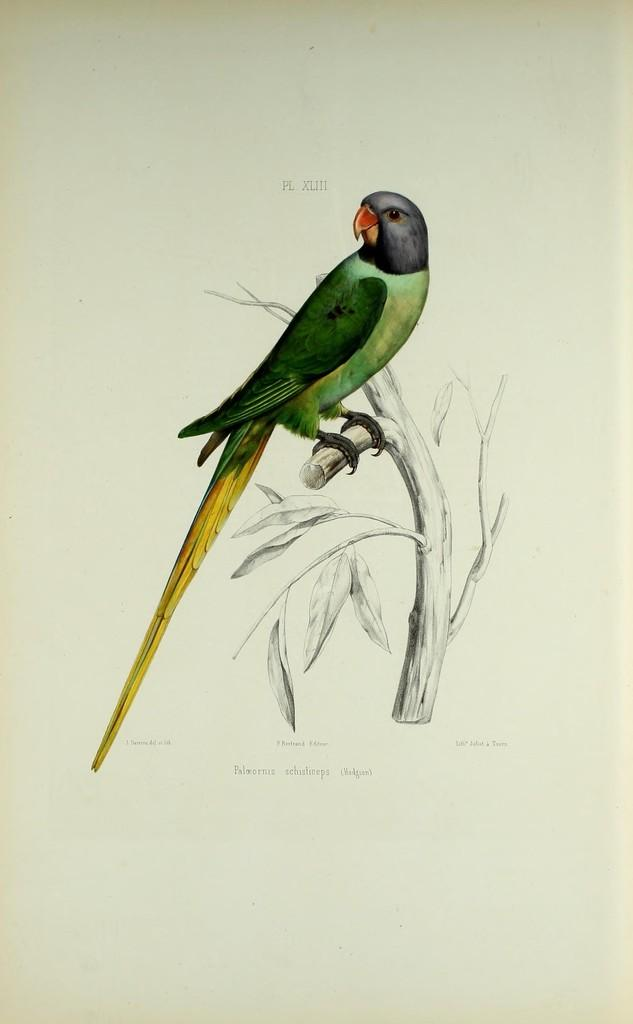What is the main subject of the image? There is a photo in the image. What is depicted in the photo? The photo contains a parrot. Where is the parrot located in the photo? The parrot is sitting on a plant. How many cats are visible in the image? There are no cats present in the image; it features a photo of a parrot sitting on a plant. What unit of measurement is used to determine the size of the country in the image? There is no country present in the image, as it only contains a photo of a parrot sitting on a plant. 